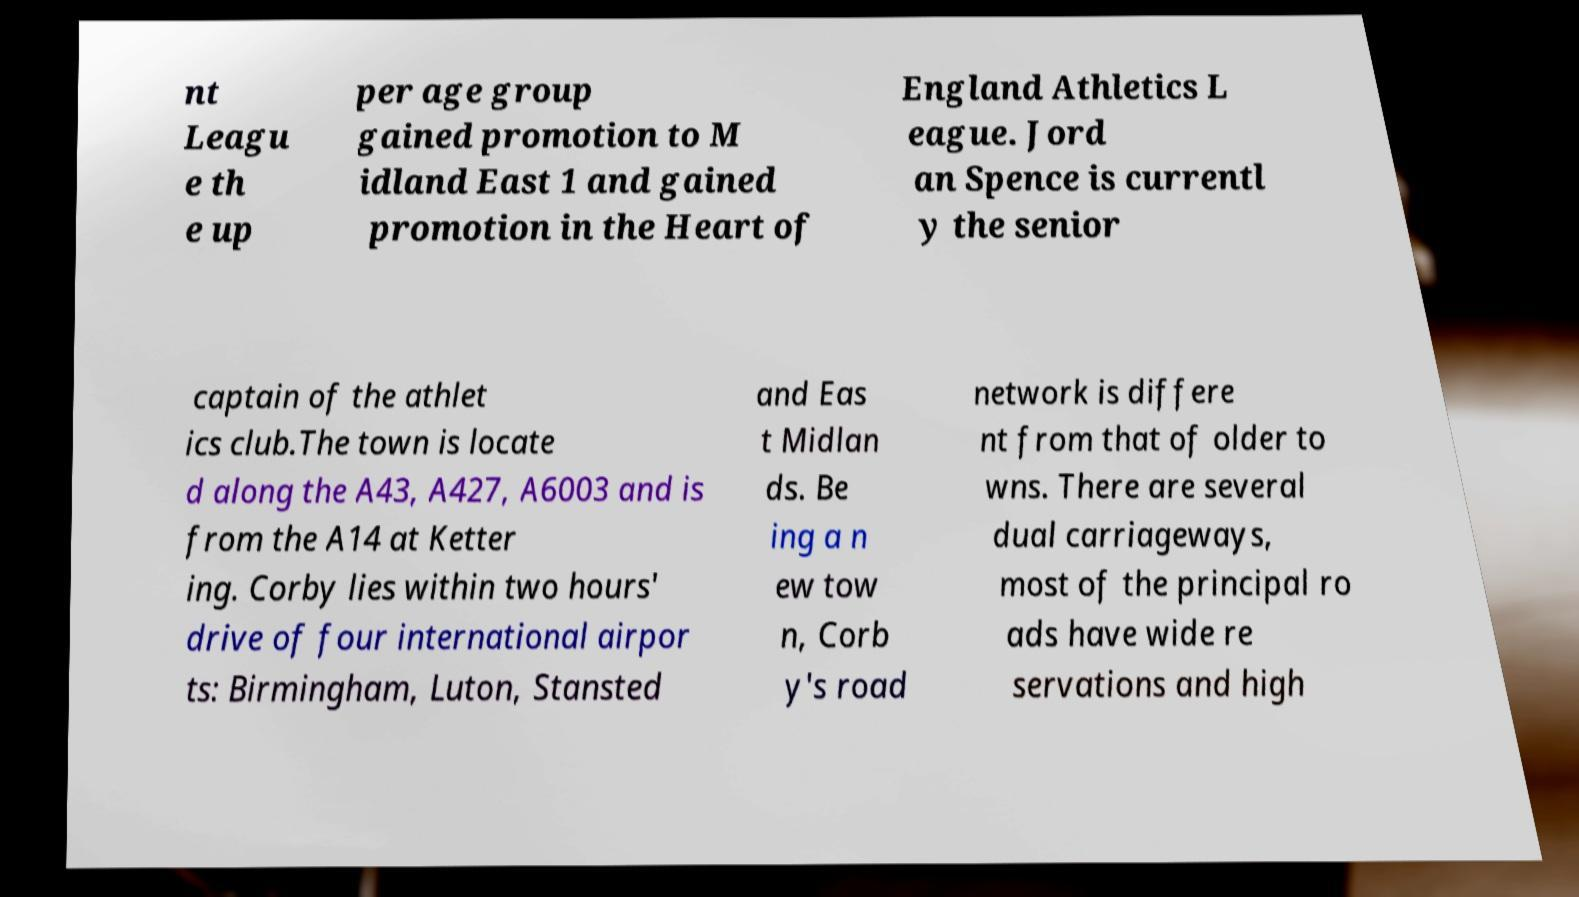For documentation purposes, I need the text within this image transcribed. Could you provide that? nt Leagu e th e up per age group gained promotion to M idland East 1 and gained promotion in the Heart of England Athletics L eague. Jord an Spence is currentl y the senior captain of the athlet ics club.The town is locate d along the A43, A427, A6003 and is from the A14 at Ketter ing. Corby lies within two hours' drive of four international airpor ts: Birmingham, Luton, Stansted and Eas t Midlan ds. Be ing a n ew tow n, Corb y's road network is differe nt from that of older to wns. There are several dual carriageways, most of the principal ro ads have wide re servations and high 